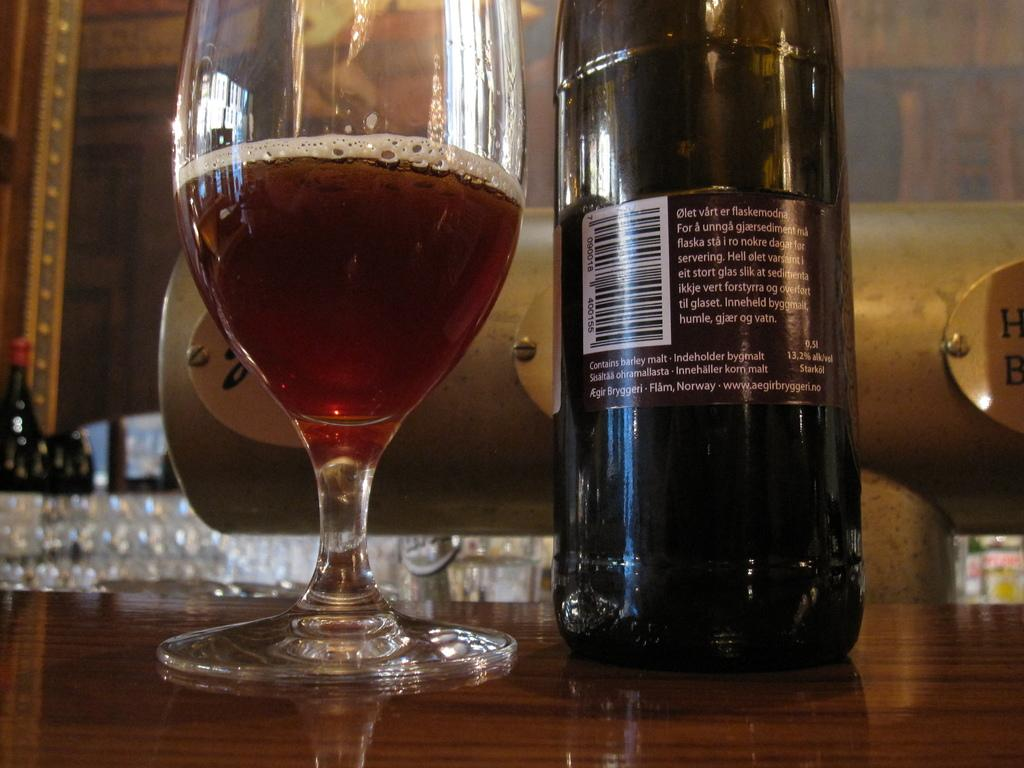<image>
Relay a brief, clear account of the picture shown. A bottle of beer has the address of Flam, Norway on its label. 